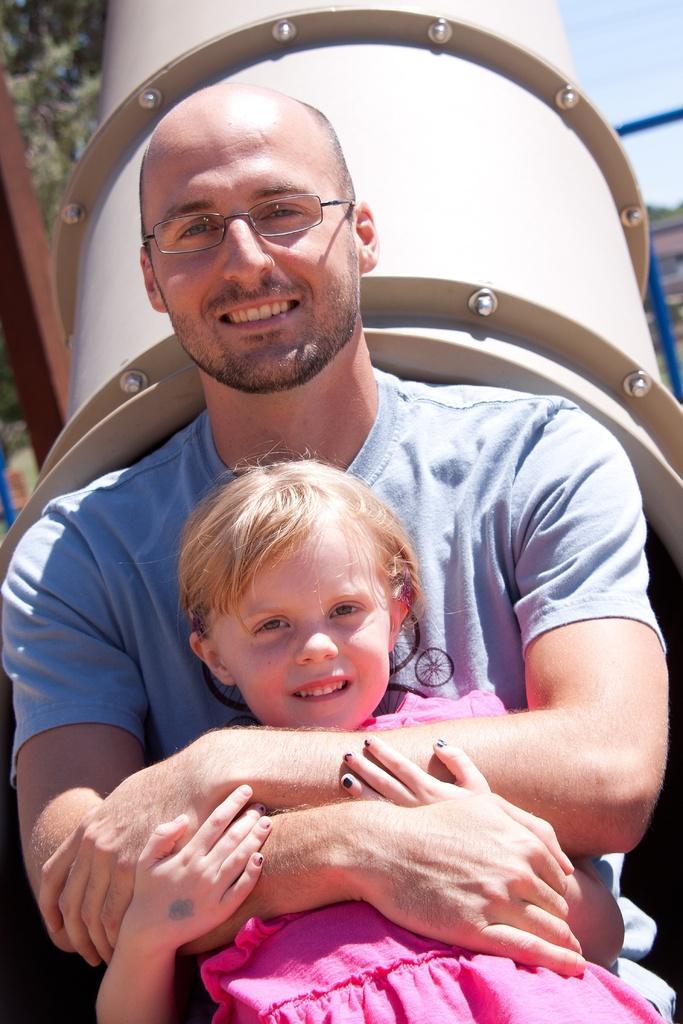How would you summarize this image in a sentence or two? In this image, we can see a man and girl are watching and smiling. Here we can see a man is holding a girl. Background we can see a pipe, rods, trees and sky. 